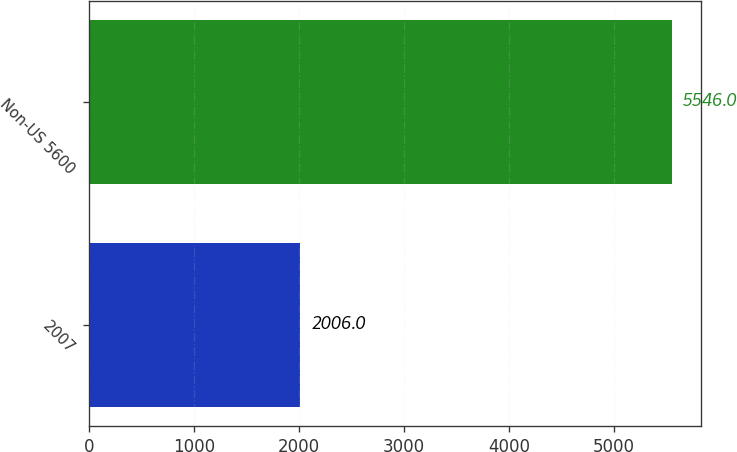<chart> <loc_0><loc_0><loc_500><loc_500><bar_chart><fcel>2007<fcel>Non-US 5600<nl><fcel>2006<fcel>5546<nl></chart> 